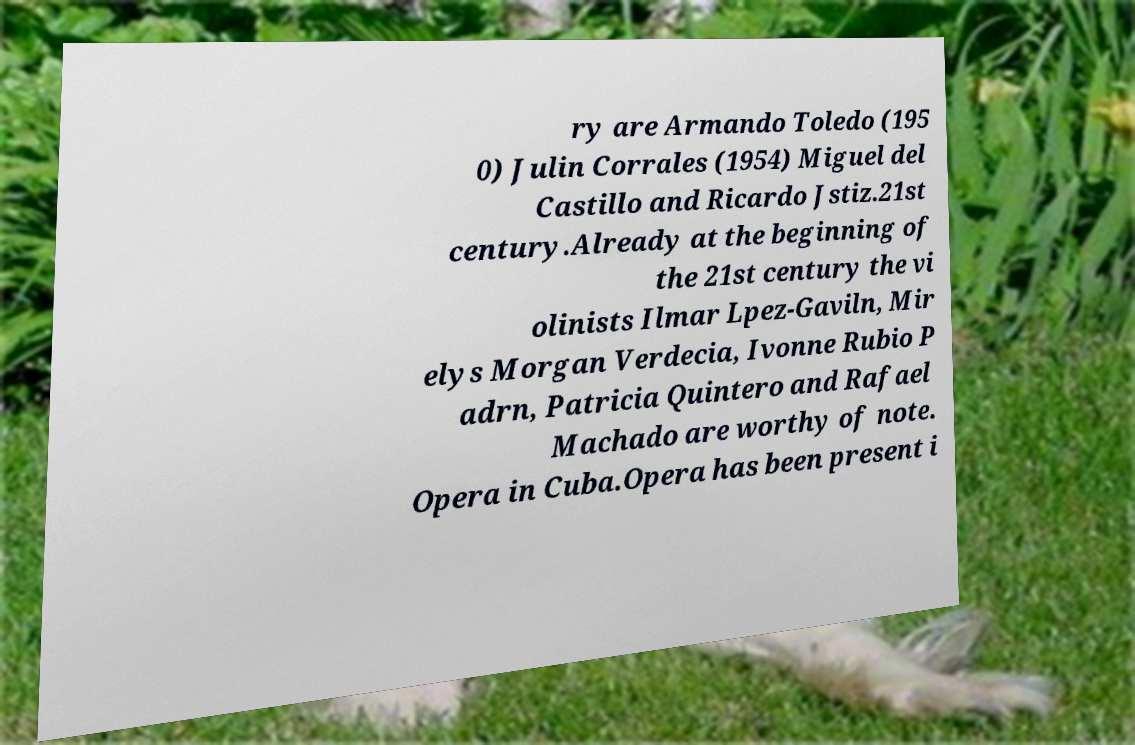Can you read and provide the text displayed in the image?This photo seems to have some interesting text. Can you extract and type it out for me? ry are Armando Toledo (195 0) Julin Corrales (1954) Miguel del Castillo and Ricardo Jstiz.21st century.Already at the beginning of the 21st century the vi olinists Ilmar Lpez-Gaviln, Mir elys Morgan Verdecia, Ivonne Rubio P adrn, Patricia Quintero and Rafael Machado are worthy of note. Opera in Cuba.Opera has been present i 